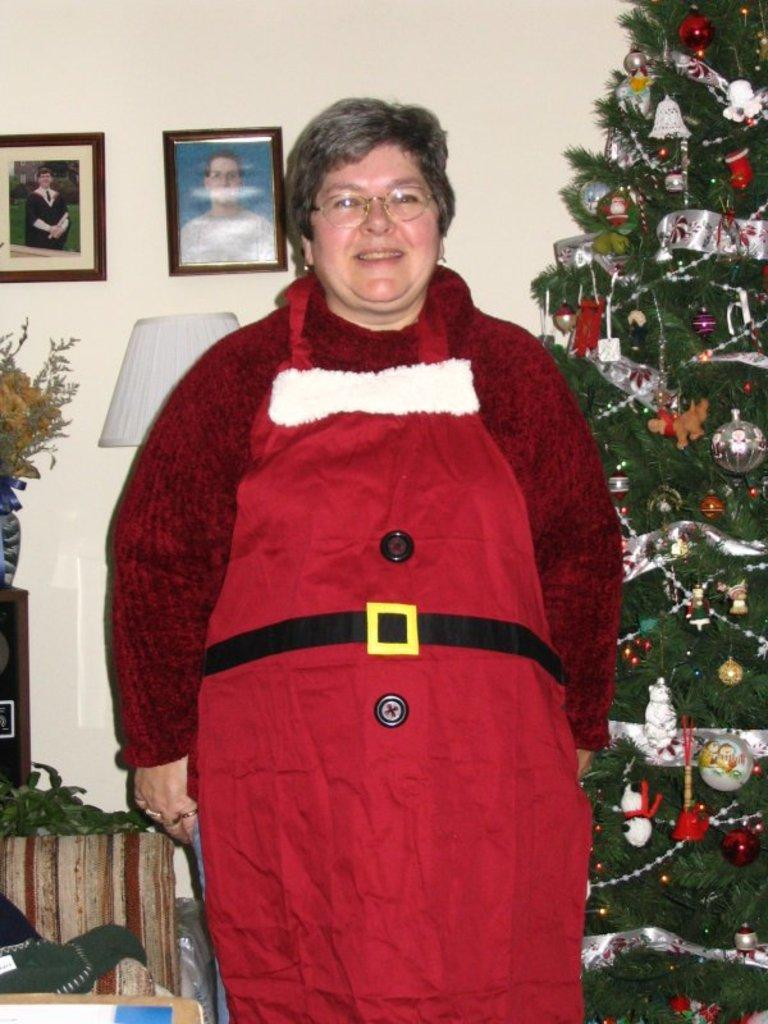Who is present in the image? There is a woman standing in the image. What is the main object in the background of the image? There is a Christmas tree in the image. What can be seen on the wall in the background of the image? Photo frames are placed on the wall in the background of the image. What news is being reported by the woman in the image? There is no news being reported in the image; the woman is simply standing. 